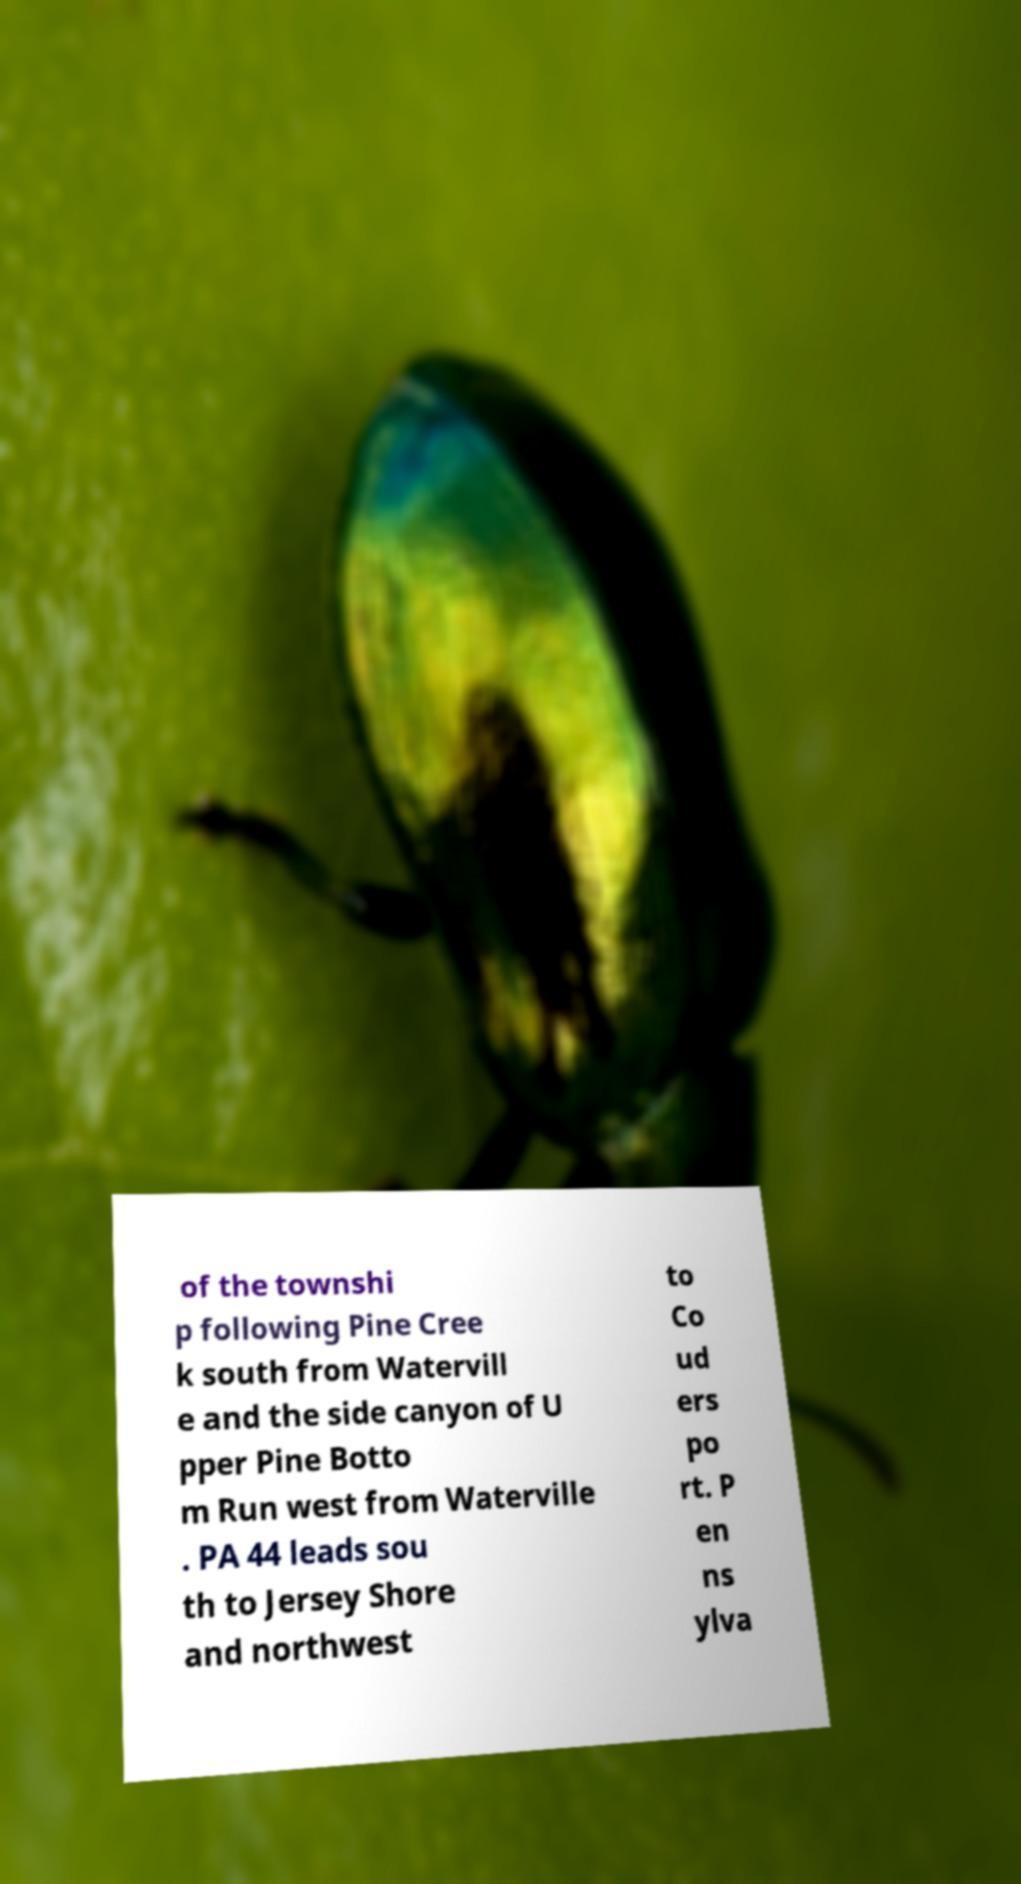Can you read and provide the text displayed in the image?This photo seems to have some interesting text. Can you extract and type it out for me? of the townshi p following Pine Cree k south from Watervill e and the side canyon of U pper Pine Botto m Run west from Waterville . PA 44 leads sou th to Jersey Shore and northwest to Co ud ers po rt. P en ns ylva 